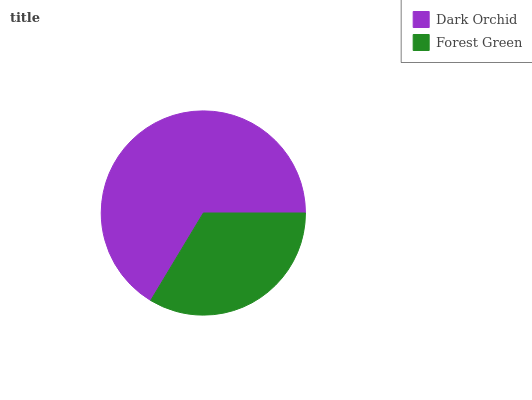Is Forest Green the minimum?
Answer yes or no. Yes. Is Dark Orchid the maximum?
Answer yes or no. Yes. Is Forest Green the maximum?
Answer yes or no. No. Is Dark Orchid greater than Forest Green?
Answer yes or no. Yes. Is Forest Green less than Dark Orchid?
Answer yes or no. Yes. Is Forest Green greater than Dark Orchid?
Answer yes or no. No. Is Dark Orchid less than Forest Green?
Answer yes or no. No. Is Dark Orchid the high median?
Answer yes or no. Yes. Is Forest Green the low median?
Answer yes or no. Yes. Is Forest Green the high median?
Answer yes or no. No. Is Dark Orchid the low median?
Answer yes or no. No. 